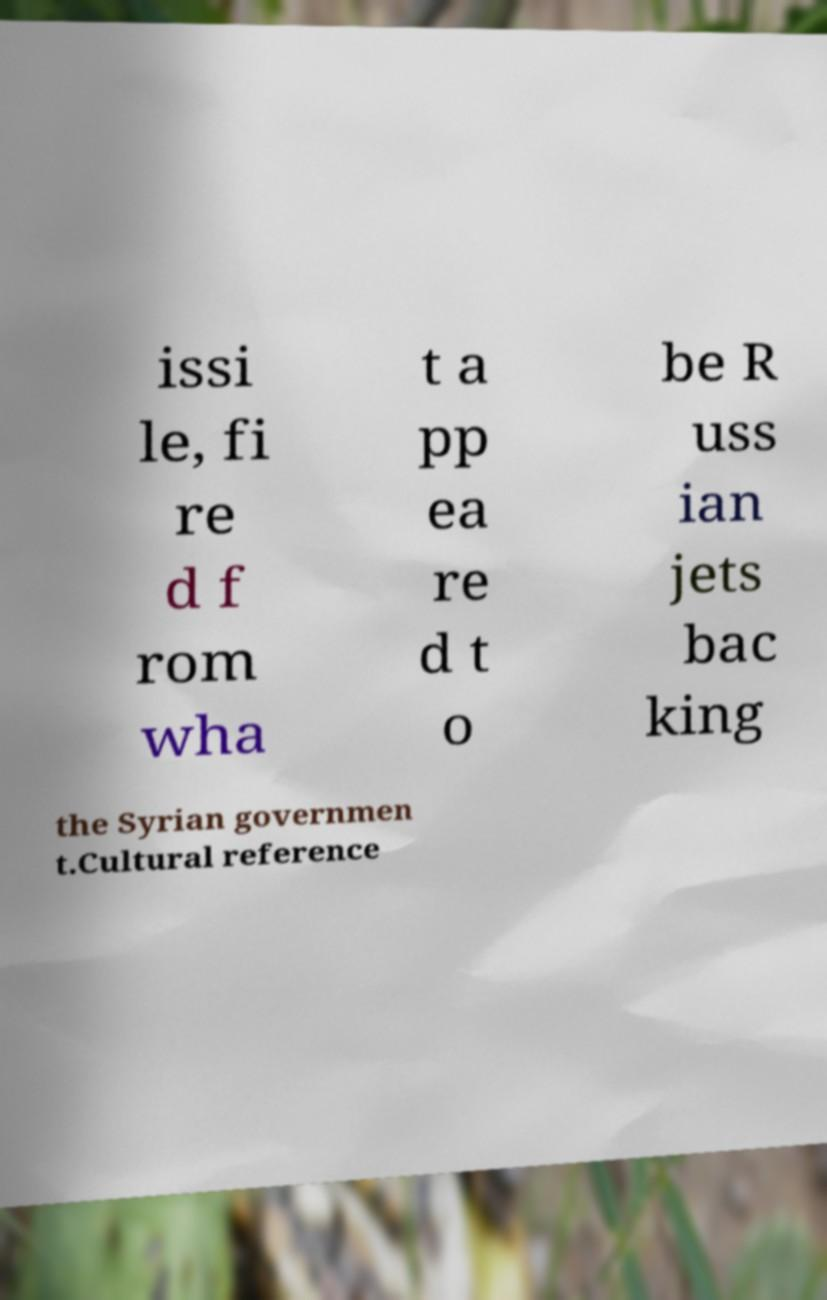There's text embedded in this image that I need extracted. Can you transcribe it verbatim? issi le, fi re d f rom wha t a pp ea re d t o be R uss ian jets bac king the Syrian governmen t.Cultural reference 